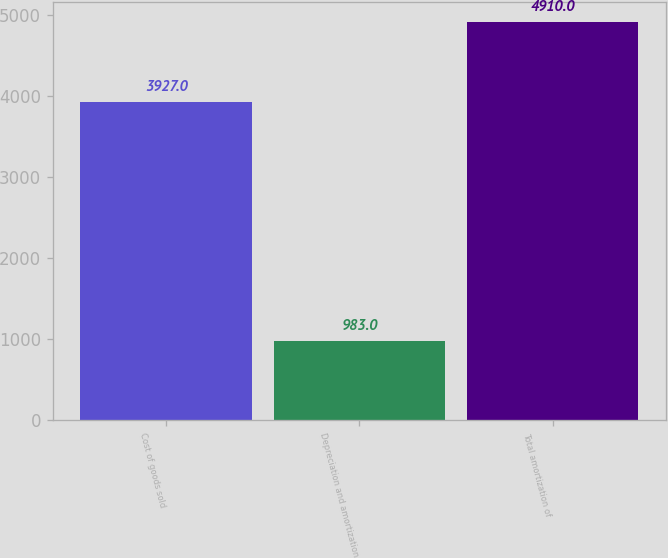<chart> <loc_0><loc_0><loc_500><loc_500><bar_chart><fcel>Cost of goods sold<fcel>Depreciation and amortization<fcel>Total amortization of<nl><fcel>3927<fcel>983<fcel>4910<nl></chart> 